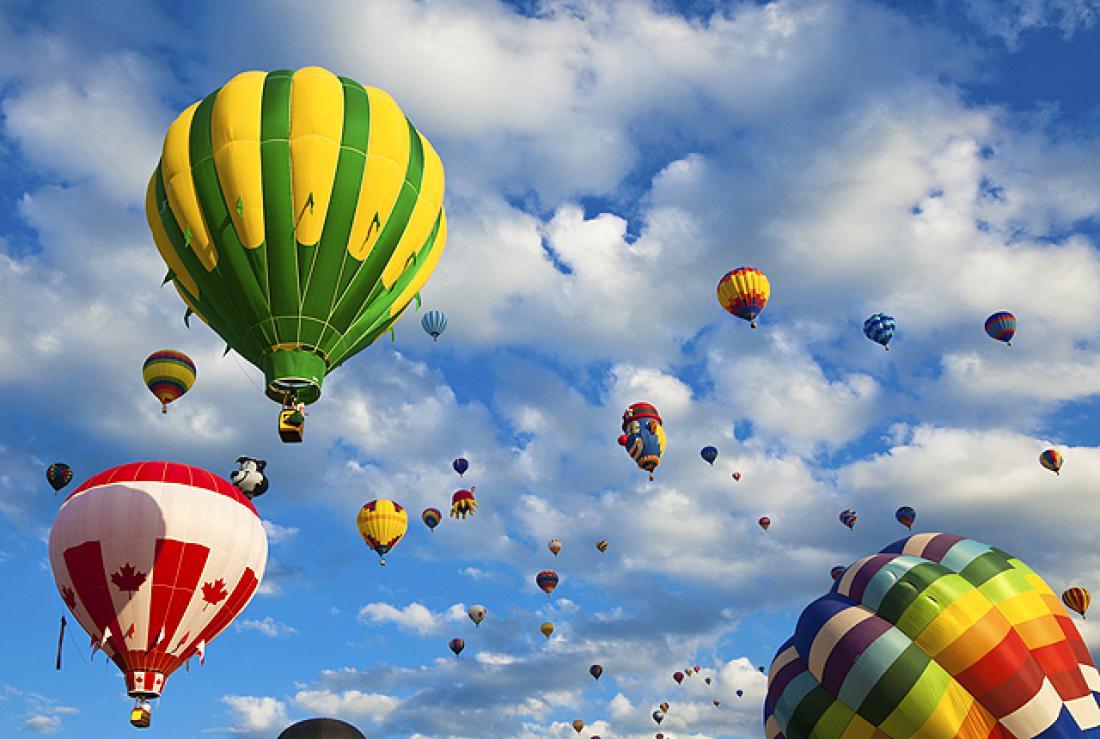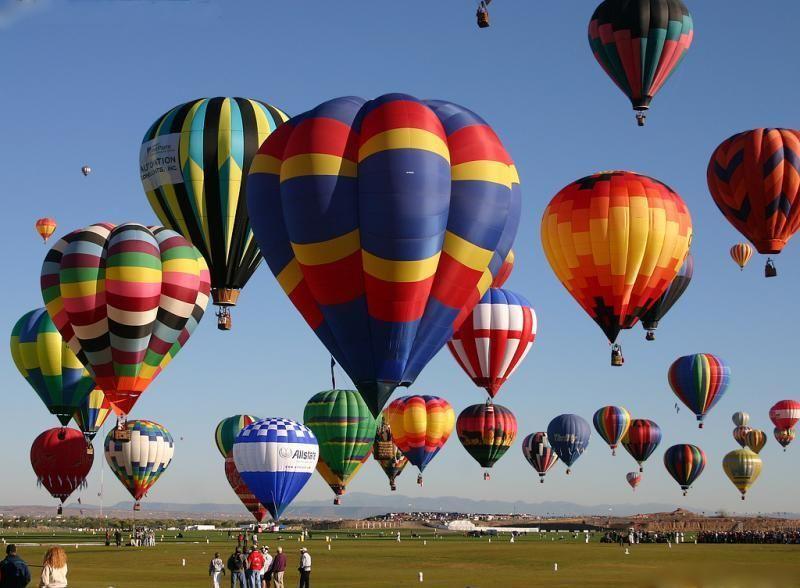The first image is the image on the left, the second image is the image on the right. Evaluate the accuracy of this statement regarding the images: "At least one balloon is shaped like an animal with legs.". Is it true? Answer yes or no. No. The first image is the image on the left, the second image is the image on the right. Evaluate the accuracy of this statement regarding the images: "There are hot air balloons floating over a body of water in the right image.". Is it true? Answer yes or no. No. 